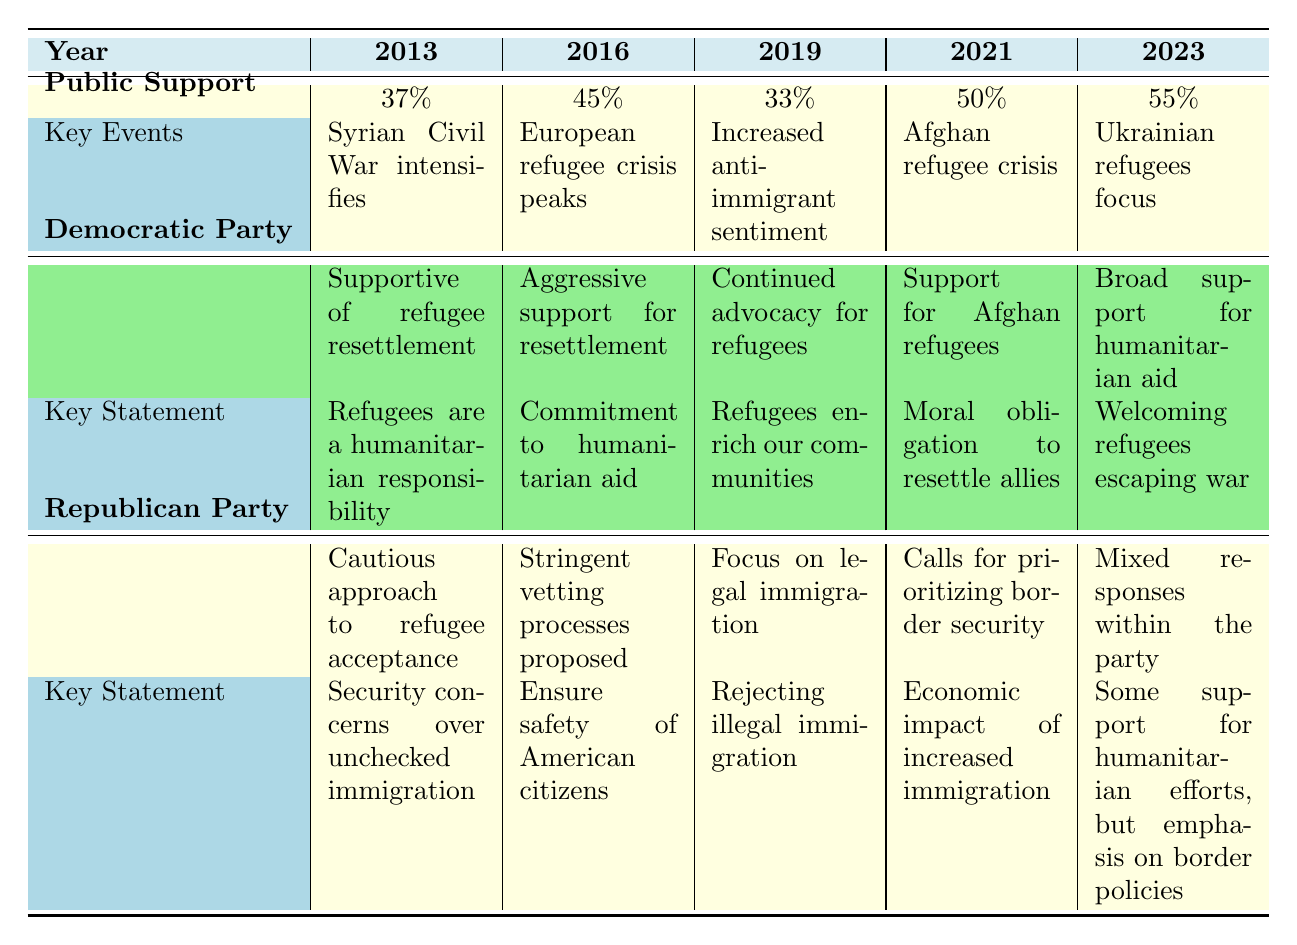What was the public support percentage for refugees in 2013? The table indicates that in the year 2013, public support for refugees was recorded at 37%. This value is taken directly from the Public Support row under the year 2013.
Answer: 37% What key event influenced public opinion in 2016? According to the table, the key event in 2016 was the peak of the European refugee crisis, which likely impacted public opinion and increased support for refugee resettlement.
Answer: European refugee crisis peaks Which party consistently advocated for refugee support across all years? The table shows that the Democratic Party maintained a position of support for refugees from 2013 through to 2023, as they continued to advocate for humanitarian aid.
Answer: Democratic Party What is the average public support percentage over the years from 2013 to 2023? To calculate the average, sum the public support percentages for each year: (37 + 45 + 33 + 50 + 55) = 220. Divide this by the number of years (5): 220/5 = 44. Therefore, the average public support is 44%.
Answer: 44% Did public support increase from 2019 to 2021? From the table, public support in 2019 was 33%, which increased to 50% in 2021. This represents a rise in support, confirming that public sentiment improved during that period.
Answer: Yes Which year saw the lowest public support for refugees? The table displays the public support percentages for each year, indicating that 2019 had the lowest support at 33%, confirmed by direct comparison with the other years listed.
Answer: 2019 How did the position of the Republican Party change from 2013 to 2023? By examining the table, the Republican Party's position shifted from a cautious approach to a more mixed response by 2023. They began with a stringent vetting process and moved towards acknowledging some support for humanitarian efforts while emphasizing border policies.
Answer: Shifted from cautious to mixed response What was a common statement made by the Democratic Party regarding refugees? The statements from the Democratic Party throughout the years emphasized humanitarian responsibility and support for resettlement, showcasing a consistent narrative of compassion towards refugees.
Answer: Humanitarian responsibility Which year experienced an increase in public support following a significant event related to refugees? The table highlights 2021 as a year where public support rose to 50% after the Afghan refugee crisis post-US withdrawal. This indicates a direct correlation between significant events and changes in public opinion.
Answer: 2021 